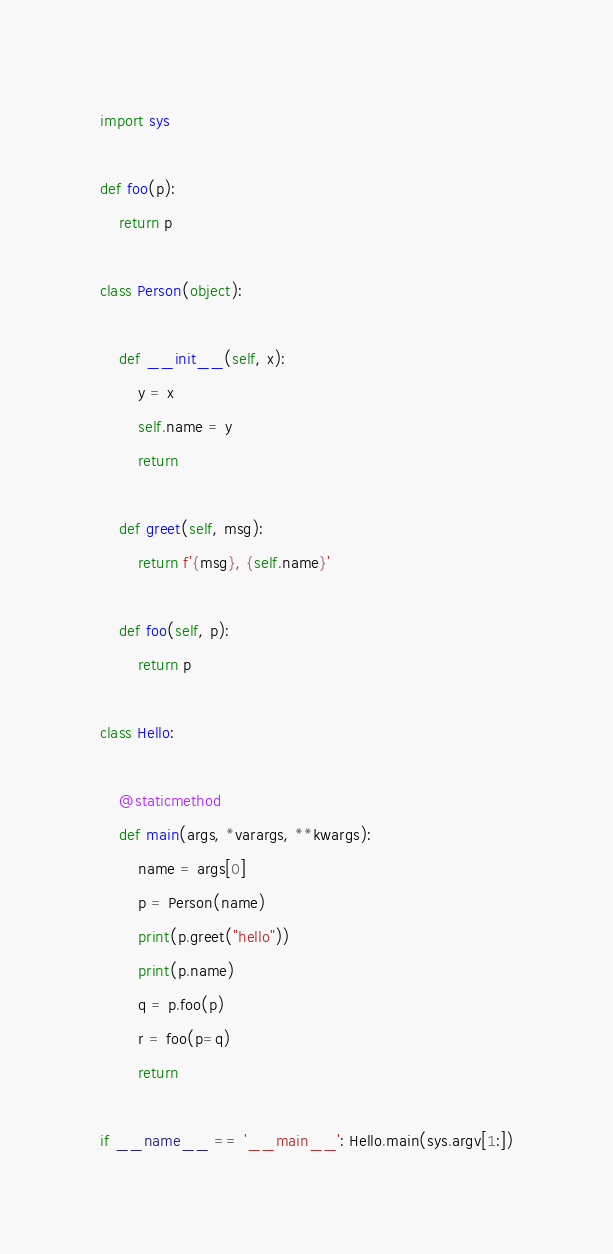Convert code to text. <code><loc_0><loc_0><loc_500><loc_500><_Python_>import sys

def foo(p):
    return p

class Person(object):

    def __init__(self, x):
        y = x
        self.name = y
        return

    def greet(self, msg):
        return f'{msg}, {self.name}'

    def foo(self, p):
        return p

class Hello:

    @staticmethod
    def main(args, *varargs, **kwargs):
        name = args[0]
        p = Person(name)
        print(p.greet("hello"))
        print(p.name)
        q = p.foo(p)
        r = foo(p=q)
        return

if __name__ == '__main__': Hello.main(sys.argv[1:])
</code> 